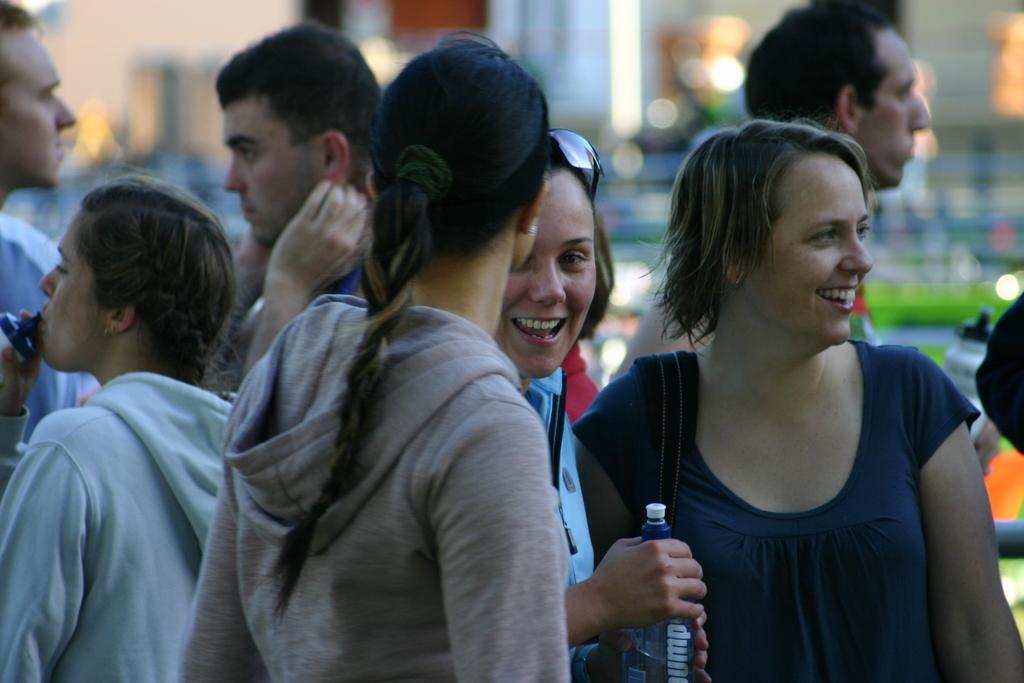How many people are present in the image? There are four women and three men in the image, making a total of seven people. What is the woman holding in her hand? One woman is holding a bottle in her hand. What type of beetle can be seen crawling on the man's shoulder in the image? There is no beetle present on anyone's shoulder in the image. How much is the quarter that the man is holding in the image? There is no quarter present in the image. 